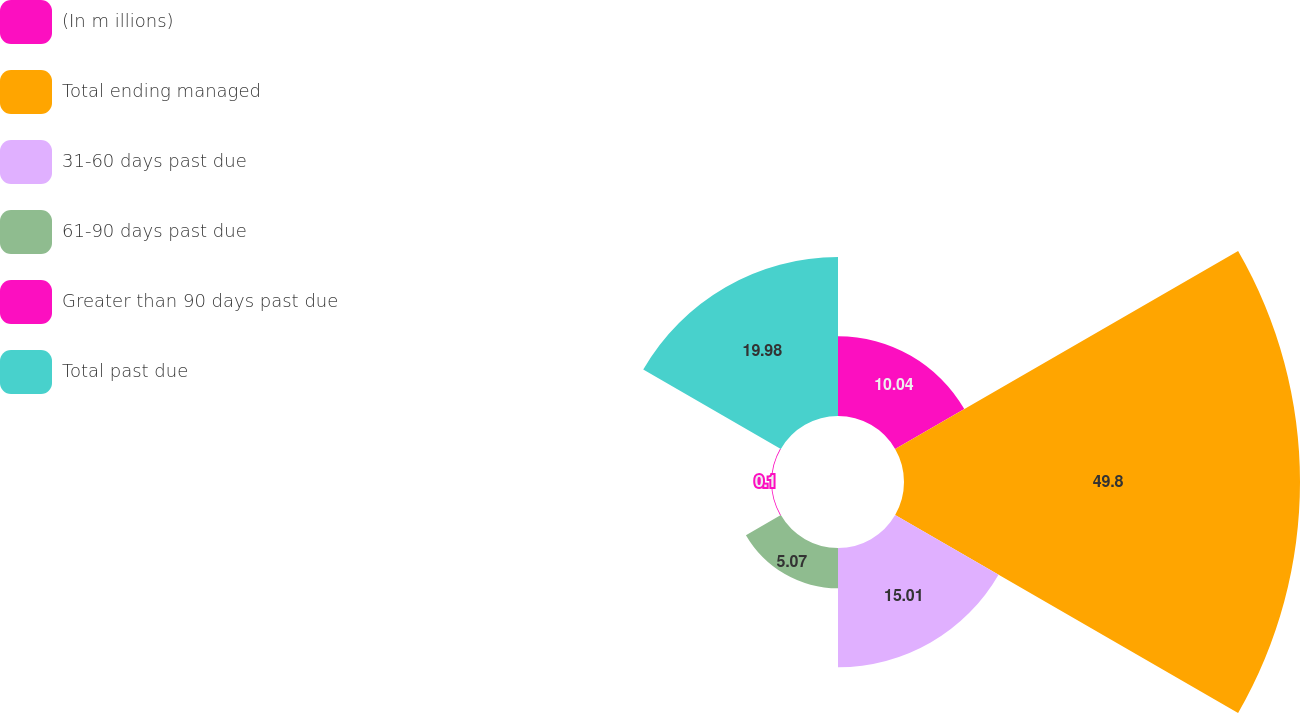<chart> <loc_0><loc_0><loc_500><loc_500><pie_chart><fcel>(In m illions)<fcel>Total ending managed<fcel>31-60 days past due<fcel>61-90 days past due<fcel>Greater than 90 days past due<fcel>Total past due<nl><fcel>10.04%<fcel>49.8%<fcel>15.01%<fcel>5.07%<fcel>0.1%<fcel>19.98%<nl></chart> 